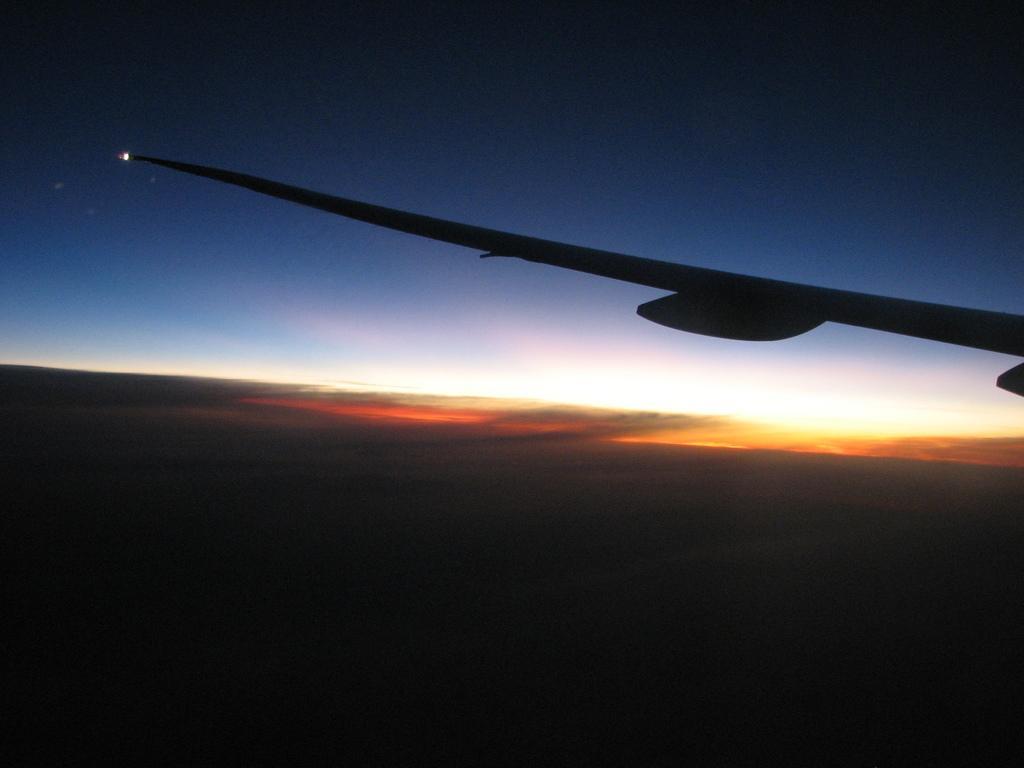Can you describe this image briefly? In this picture we can see a wing of an airplane on the right side, there is the sky at the top of the picture. 